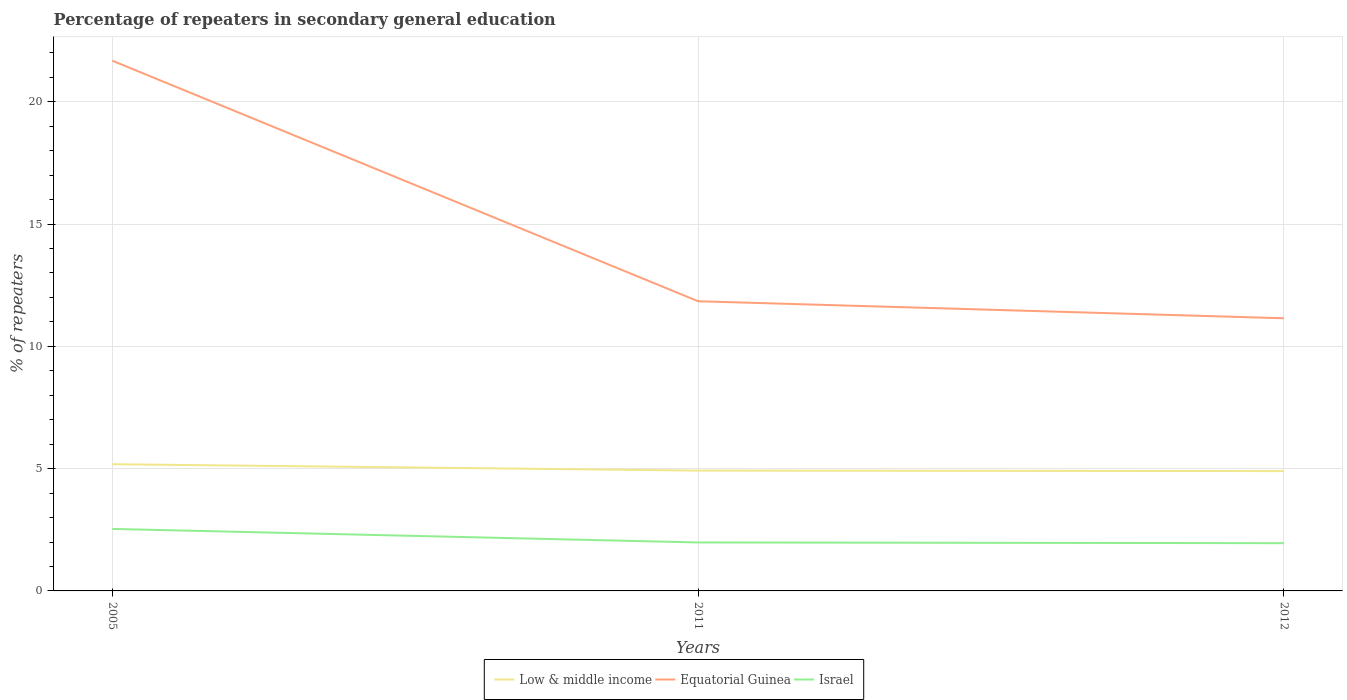How many different coloured lines are there?
Offer a very short reply. 3. Across all years, what is the maximum percentage of repeaters in secondary general education in Israel?
Keep it short and to the point. 1.95. What is the total percentage of repeaters in secondary general education in Equatorial Guinea in the graph?
Keep it short and to the point. 9.84. What is the difference between the highest and the second highest percentage of repeaters in secondary general education in Low & middle income?
Make the answer very short. 0.28. What is the difference between the highest and the lowest percentage of repeaters in secondary general education in Israel?
Make the answer very short. 1. How many years are there in the graph?
Ensure brevity in your answer.  3. What is the difference between two consecutive major ticks on the Y-axis?
Provide a succinct answer. 5. Does the graph contain any zero values?
Provide a succinct answer. No. Does the graph contain grids?
Your response must be concise. Yes. What is the title of the graph?
Make the answer very short. Percentage of repeaters in secondary general education. What is the label or title of the X-axis?
Offer a terse response. Years. What is the label or title of the Y-axis?
Provide a succinct answer. % of repeaters. What is the % of repeaters of Low & middle income in 2005?
Offer a terse response. 5.18. What is the % of repeaters in Equatorial Guinea in 2005?
Your response must be concise. 21.68. What is the % of repeaters of Israel in 2005?
Make the answer very short. 2.53. What is the % of repeaters in Low & middle income in 2011?
Provide a short and direct response. 4.92. What is the % of repeaters of Equatorial Guinea in 2011?
Provide a succinct answer. 11.84. What is the % of repeaters of Israel in 2011?
Ensure brevity in your answer.  1.98. What is the % of repeaters of Low & middle income in 2012?
Your response must be concise. 4.9. What is the % of repeaters of Equatorial Guinea in 2012?
Provide a succinct answer. 11.15. What is the % of repeaters of Israel in 2012?
Provide a succinct answer. 1.95. Across all years, what is the maximum % of repeaters of Low & middle income?
Give a very brief answer. 5.18. Across all years, what is the maximum % of repeaters of Equatorial Guinea?
Your response must be concise. 21.68. Across all years, what is the maximum % of repeaters in Israel?
Offer a very short reply. 2.53. Across all years, what is the minimum % of repeaters in Low & middle income?
Give a very brief answer. 4.9. Across all years, what is the minimum % of repeaters of Equatorial Guinea?
Your answer should be compact. 11.15. Across all years, what is the minimum % of repeaters in Israel?
Offer a very short reply. 1.95. What is the total % of repeaters in Low & middle income in the graph?
Provide a short and direct response. 15. What is the total % of repeaters in Equatorial Guinea in the graph?
Offer a terse response. 44.67. What is the total % of repeaters of Israel in the graph?
Offer a very short reply. 6.47. What is the difference between the % of repeaters in Low & middle income in 2005 and that in 2011?
Make the answer very short. 0.26. What is the difference between the % of repeaters in Equatorial Guinea in 2005 and that in 2011?
Your response must be concise. 9.84. What is the difference between the % of repeaters of Israel in 2005 and that in 2011?
Give a very brief answer. 0.55. What is the difference between the % of repeaters in Low & middle income in 2005 and that in 2012?
Offer a very short reply. 0.28. What is the difference between the % of repeaters of Equatorial Guinea in 2005 and that in 2012?
Offer a terse response. 10.53. What is the difference between the % of repeaters of Israel in 2005 and that in 2012?
Your answer should be compact. 0.58. What is the difference between the % of repeaters of Low & middle income in 2011 and that in 2012?
Give a very brief answer. 0.02. What is the difference between the % of repeaters of Equatorial Guinea in 2011 and that in 2012?
Your answer should be compact. 0.7. What is the difference between the % of repeaters of Israel in 2011 and that in 2012?
Make the answer very short. 0.03. What is the difference between the % of repeaters of Low & middle income in 2005 and the % of repeaters of Equatorial Guinea in 2011?
Your answer should be compact. -6.66. What is the difference between the % of repeaters of Low & middle income in 2005 and the % of repeaters of Israel in 2011?
Keep it short and to the point. 3.2. What is the difference between the % of repeaters of Equatorial Guinea in 2005 and the % of repeaters of Israel in 2011?
Your answer should be compact. 19.7. What is the difference between the % of repeaters in Low & middle income in 2005 and the % of repeaters in Equatorial Guinea in 2012?
Your response must be concise. -5.97. What is the difference between the % of repeaters of Low & middle income in 2005 and the % of repeaters of Israel in 2012?
Offer a terse response. 3.23. What is the difference between the % of repeaters of Equatorial Guinea in 2005 and the % of repeaters of Israel in 2012?
Keep it short and to the point. 19.73. What is the difference between the % of repeaters in Low & middle income in 2011 and the % of repeaters in Equatorial Guinea in 2012?
Provide a short and direct response. -6.23. What is the difference between the % of repeaters in Low & middle income in 2011 and the % of repeaters in Israel in 2012?
Ensure brevity in your answer.  2.97. What is the difference between the % of repeaters of Equatorial Guinea in 2011 and the % of repeaters of Israel in 2012?
Offer a terse response. 9.89. What is the average % of repeaters of Equatorial Guinea per year?
Keep it short and to the point. 14.89. What is the average % of repeaters in Israel per year?
Offer a very short reply. 2.16. In the year 2005, what is the difference between the % of repeaters of Low & middle income and % of repeaters of Equatorial Guinea?
Give a very brief answer. -16.5. In the year 2005, what is the difference between the % of repeaters of Low & middle income and % of repeaters of Israel?
Ensure brevity in your answer.  2.65. In the year 2005, what is the difference between the % of repeaters in Equatorial Guinea and % of repeaters in Israel?
Ensure brevity in your answer.  19.14. In the year 2011, what is the difference between the % of repeaters of Low & middle income and % of repeaters of Equatorial Guinea?
Provide a succinct answer. -6.92. In the year 2011, what is the difference between the % of repeaters in Low & middle income and % of repeaters in Israel?
Your response must be concise. 2.94. In the year 2011, what is the difference between the % of repeaters in Equatorial Guinea and % of repeaters in Israel?
Keep it short and to the point. 9.86. In the year 2012, what is the difference between the % of repeaters in Low & middle income and % of repeaters in Equatorial Guinea?
Your answer should be compact. -6.25. In the year 2012, what is the difference between the % of repeaters in Low & middle income and % of repeaters in Israel?
Offer a terse response. 2.95. In the year 2012, what is the difference between the % of repeaters in Equatorial Guinea and % of repeaters in Israel?
Your response must be concise. 9.2. What is the ratio of the % of repeaters in Low & middle income in 2005 to that in 2011?
Provide a short and direct response. 1.05. What is the ratio of the % of repeaters in Equatorial Guinea in 2005 to that in 2011?
Your answer should be very brief. 1.83. What is the ratio of the % of repeaters in Israel in 2005 to that in 2011?
Keep it short and to the point. 1.28. What is the ratio of the % of repeaters of Low & middle income in 2005 to that in 2012?
Your answer should be very brief. 1.06. What is the ratio of the % of repeaters in Equatorial Guinea in 2005 to that in 2012?
Offer a terse response. 1.94. What is the ratio of the % of repeaters of Israel in 2005 to that in 2012?
Ensure brevity in your answer.  1.3. What is the ratio of the % of repeaters in Equatorial Guinea in 2011 to that in 2012?
Keep it short and to the point. 1.06. What is the ratio of the % of repeaters in Israel in 2011 to that in 2012?
Your answer should be very brief. 1.01. What is the difference between the highest and the second highest % of repeaters in Low & middle income?
Your response must be concise. 0.26. What is the difference between the highest and the second highest % of repeaters of Equatorial Guinea?
Offer a terse response. 9.84. What is the difference between the highest and the second highest % of repeaters in Israel?
Keep it short and to the point. 0.55. What is the difference between the highest and the lowest % of repeaters of Low & middle income?
Provide a short and direct response. 0.28. What is the difference between the highest and the lowest % of repeaters in Equatorial Guinea?
Offer a terse response. 10.53. What is the difference between the highest and the lowest % of repeaters in Israel?
Provide a short and direct response. 0.58. 